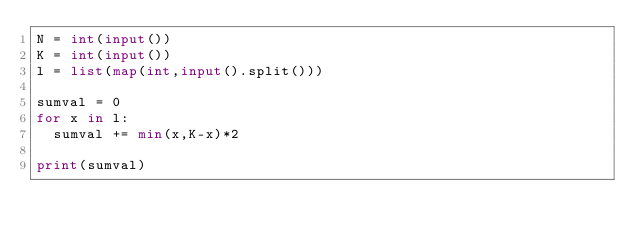<code> <loc_0><loc_0><loc_500><loc_500><_Python_>N = int(input())
K = int(input())
l = list(map(int,input().split()))

sumval = 0
for x in l:
  sumval += min(x,K-x)*2

print(sumval)</code> 